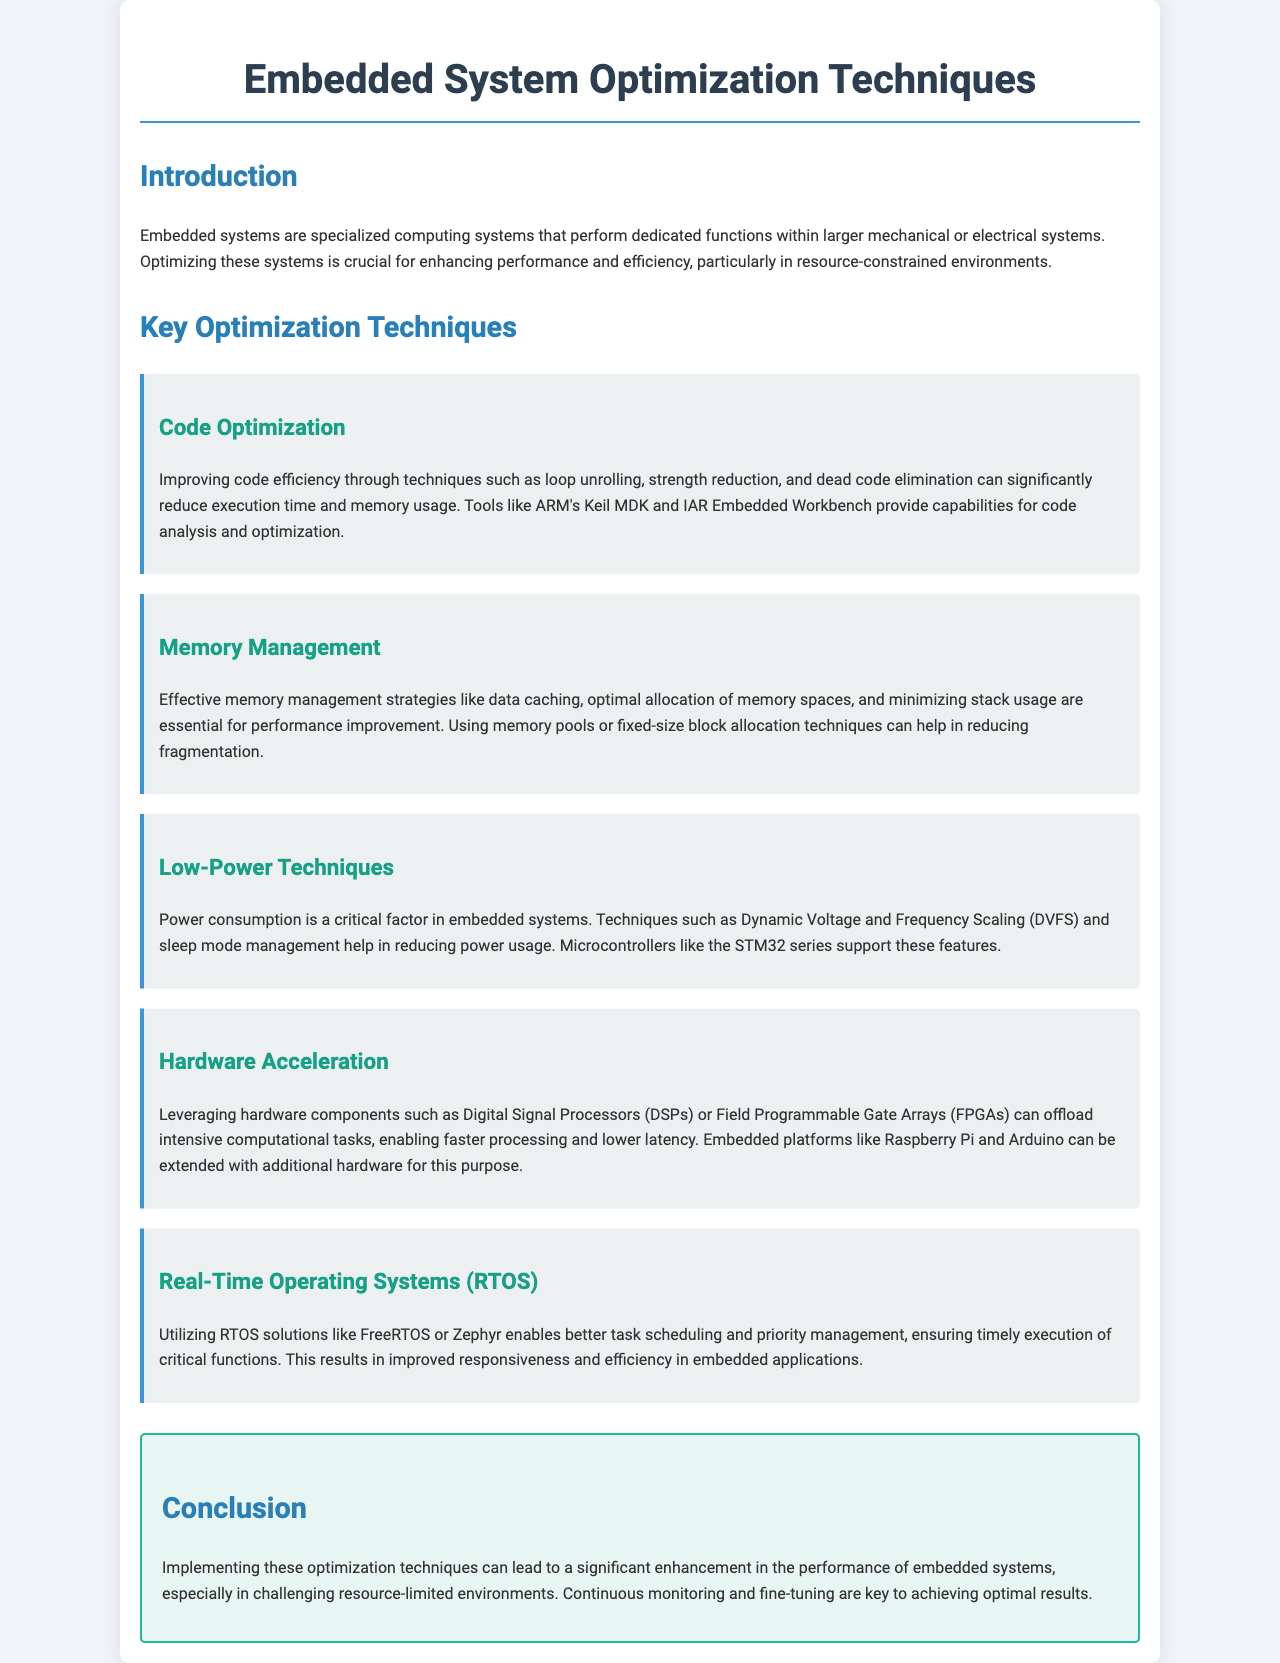What is the title of the brochure? The title is prominently displayed at the top of the document, indicating the main topic covered.
Answer: Embedded System Optimization Techniques What is one tool mentioned for code analysis? The brochure lists tools that assist in code optimization and analysis within the document's content.
Answer: ARM's Keil MDK What technique is focused on power consumption? The document categorizes various optimization techniques to address critical concerns in embedded systems.
Answer: Low-Power Techniques Which operating systems are mentioned as RTOS options? The text specifically provides examples of real-time operating systems that enhance task scheduling in embedded applications.
Answer: FreeRTOS or Zephyr What is a method to improve memory management? The brochure describes techniques essential for enhancing performance in resource-constrained environments.
Answer: Data caching What is one hardware component mentioned for acceleration? The document refers to specific hardware elements that can be leveraged for performance improvement.
Answer: Digital Signal Processors (DSPs) How does implementing optimization techniques affect performance? The conclusion section summarizes the impact of the techniques discussed throughout the brochure.
Answer: Significant enhancement What is the main focus of the introduction? The introductory section outlines the general importance and application of embedded systems and their optimization.
Answer: Performance and efficiency What color is used for the heading of the techniques section? The document stylizes sections to provide visual cues for the reader, including color coding for headings.
Answer: Blue 